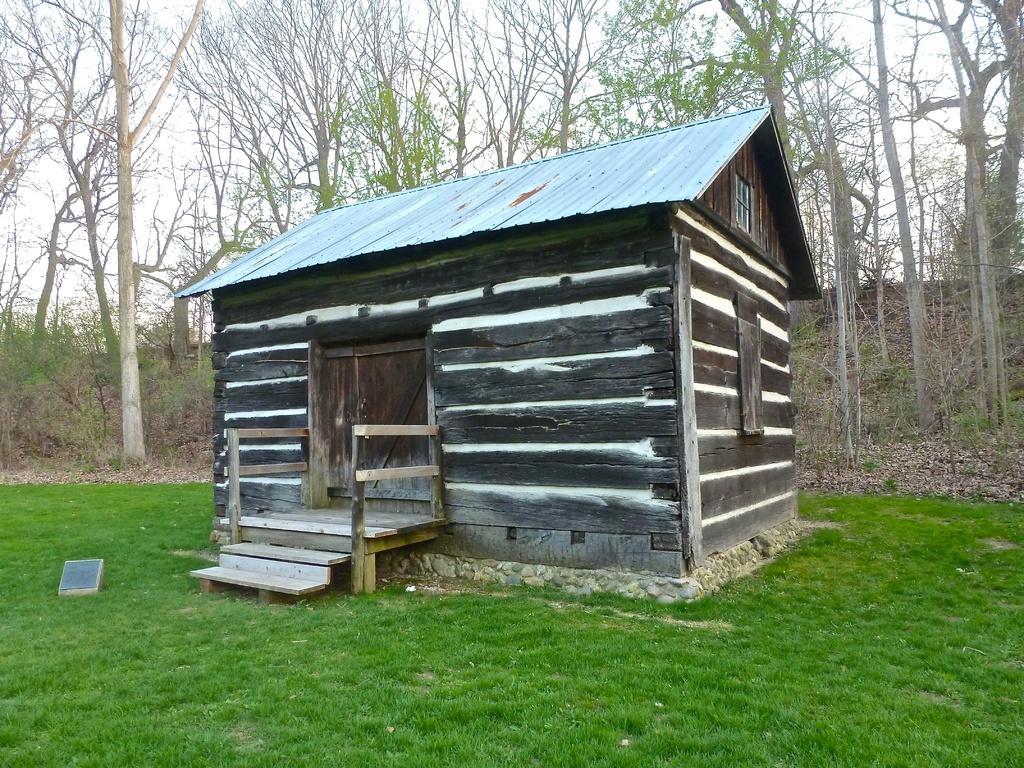In one or two sentences, can you explain what this image depicts? In the image we can see there is a ground covered with grass and there is a wooden house. There is a iron sheet roof on top of the house and behind there are lot of trees. 